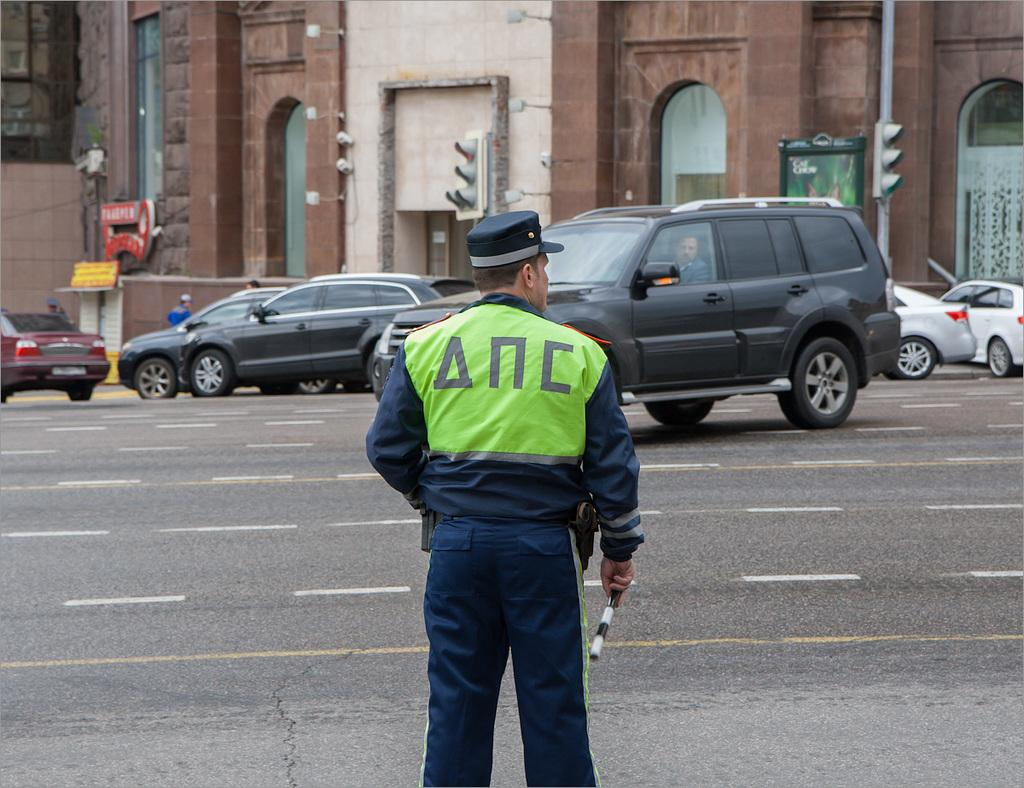What is the main subject of the image? There is a person standing in the image. What else can be seen on the road in the image? There are vehicles on the road in the image, and a person is sitting inside one of them. What type of structure is visible in the image? There is a building in the image. What are the signal poles used for in the image? The signal poles are used for traffic control in the image. How many people are visible in the image, and where are they located? There are at least two people visible in the image, one standing and others standing far from the person standing person. What type of soup is being served in the image? There is no soup present in the image. 